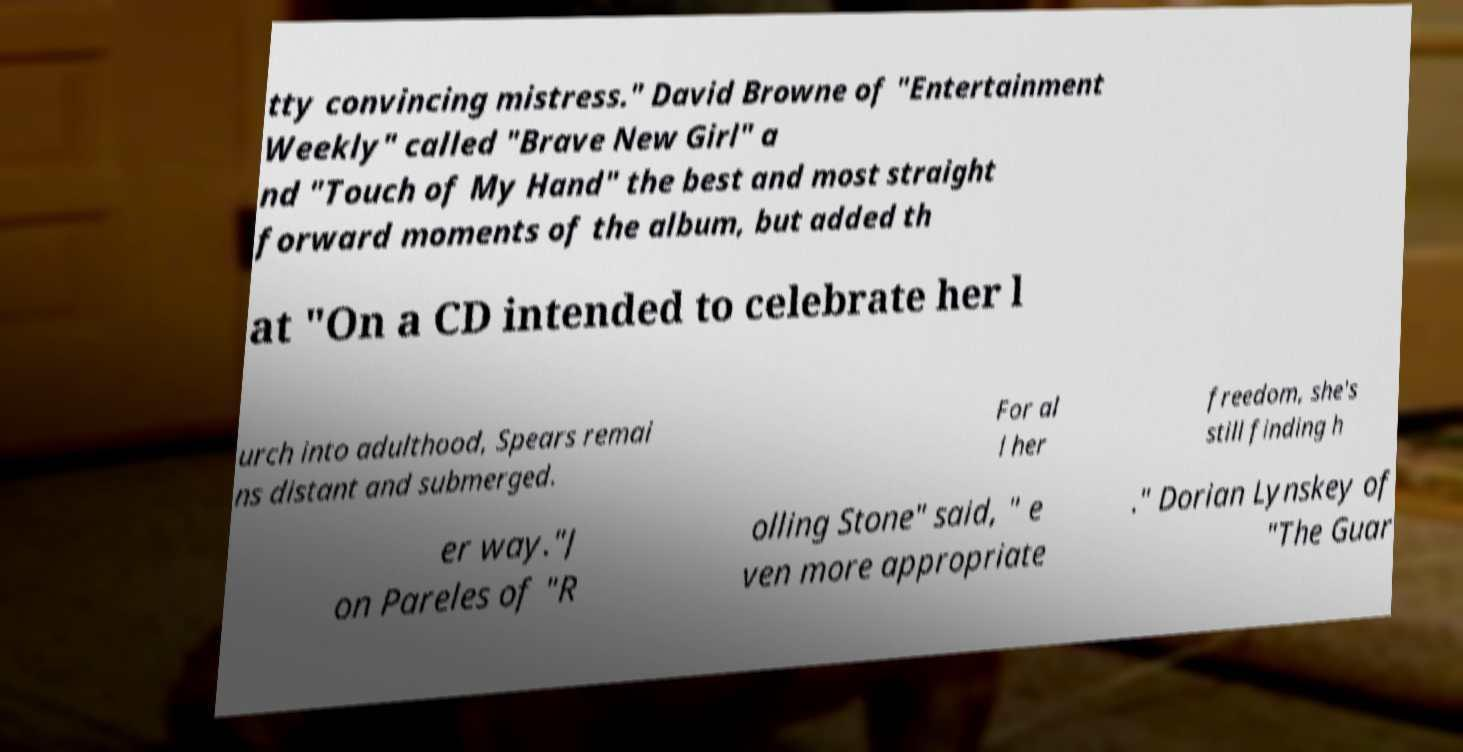For documentation purposes, I need the text within this image transcribed. Could you provide that? tty convincing mistress." David Browne of "Entertainment Weekly" called "Brave New Girl" a nd "Touch of My Hand" the best and most straight forward moments of the album, but added th at "On a CD intended to celebrate her l urch into adulthood, Spears remai ns distant and submerged. For al l her freedom, she's still finding h er way."J on Pareles of "R olling Stone" said, " e ven more appropriate ." Dorian Lynskey of "The Guar 